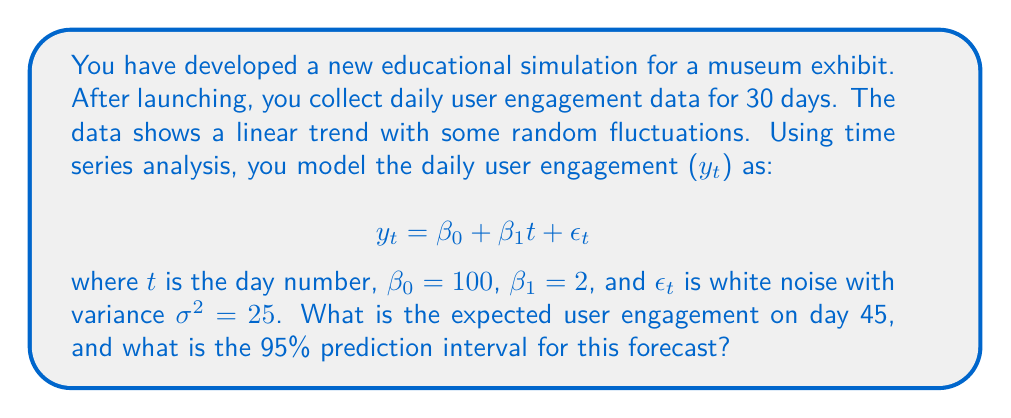Can you answer this question? To solve this problem, we'll follow these steps:

1. Calculate the expected user engagement on day 45:
   The expected value is given by the deterministic part of the model:
   $$E[y_{45}] = \beta_0 + \beta_1 \cdot 45$$
   $$E[y_{45}] = 100 + 2 \cdot 45 = 100 + 90 = 190$$

2. Calculate the standard error of the forecast:
   For a linear trend model, the standard error of the forecast at time $h$ steps ahead is:
   $$SE(h) = \sigma\sqrt{1 + \frac{h^2}{n(n^2-1)}}$$
   where $n$ is the number of observations used to fit the model (30 in this case).
   $$SE(15) = 5\sqrt{1 + \frac{15^2}{30(30^2-1)}} \approx 5.1962$$

3. Calculate the 95% prediction interval:
   For a 95% interval, we use the 97.5th percentile of the standard normal distribution, which is approximately 1.96.
   The interval is given by:
   $$[E[y_{45}] - 1.96 \cdot SE(15), E[y_{45}] + 1.96 \cdot SE(15)]$$
   $$[190 - 1.96 \cdot 5.1962, 190 + 1.96 \cdot 5.1962]$$
   $$[179.8145, 200.1855]$$

Therefore, the expected user engagement on day 45 is 190, and the 95% prediction interval is approximately [179.8, 200.2].
Answer: Expected engagement: 190; 95% PI: [179.8, 200.2] 